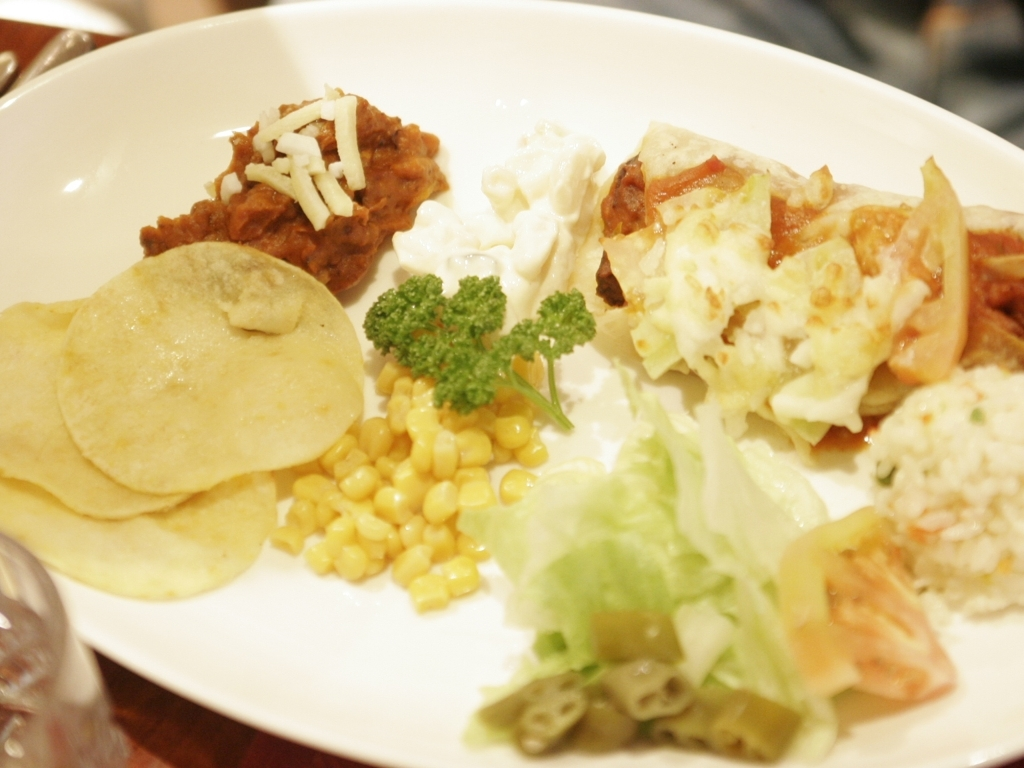This meal appears to have influences from various cuisines. Can you suggest a beverage that would pair well with it? Given the diverse flavors on the plate, a beverage that could complement the meal without overwhelming any single component would be ideal. A glass of light, crisp white wine or a sparkling water with a twist of lime could refresh the palate between bites. For non-alcoholic options, an iced herbal tea with subtle flavors like lemongrass or mint would be lovely. 